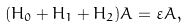Convert formula to latex. <formula><loc_0><loc_0><loc_500><loc_500>( H _ { 0 } + H _ { 1 } + H _ { 2 } ) { A } = \varepsilon { A } ,</formula> 